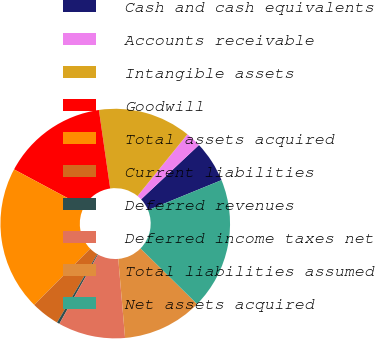Convert chart. <chart><loc_0><loc_0><loc_500><loc_500><pie_chart><fcel>Cash and cash equivalents<fcel>Accounts receivable<fcel>Intangible assets<fcel>Goodwill<fcel>Total assets acquired<fcel>Current liabilities<fcel>Deferred revenues<fcel>Deferred income taxes net<fcel>Total liabilities assumed<fcel>Net assets acquired<nl><fcel>5.82%<fcel>2.19%<fcel>13.09%<fcel>14.9%<fcel>20.35%<fcel>4.01%<fcel>0.37%<fcel>9.46%<fcel>11.27%<fcel>18.54%<nl></chart> 